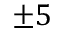Convert formula to latex. <formula><loc_0><loc_0><loc_500><loc_500>\pm 5</formula> 